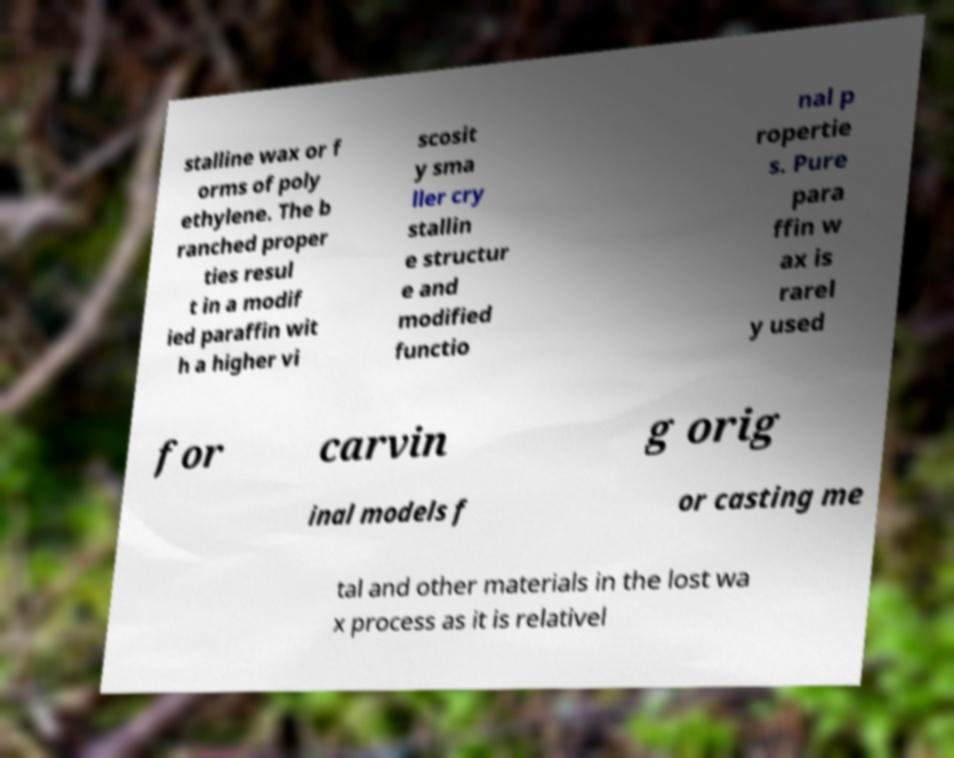What messages or text are displayed in this image? I need them in a readable, typed format. stalline wax or f orms of poly ethylene. The b ranched proper ties resul t in a modif ied paraffin wit h a higher vi scosit y sma ller cry stallin e structur e and modified functio nal p ropertie s. Pure para ffin w ax is rarel y used for carvin g orig inal models f or casting me tal and other materials in the lost wa x process as it is relativel 